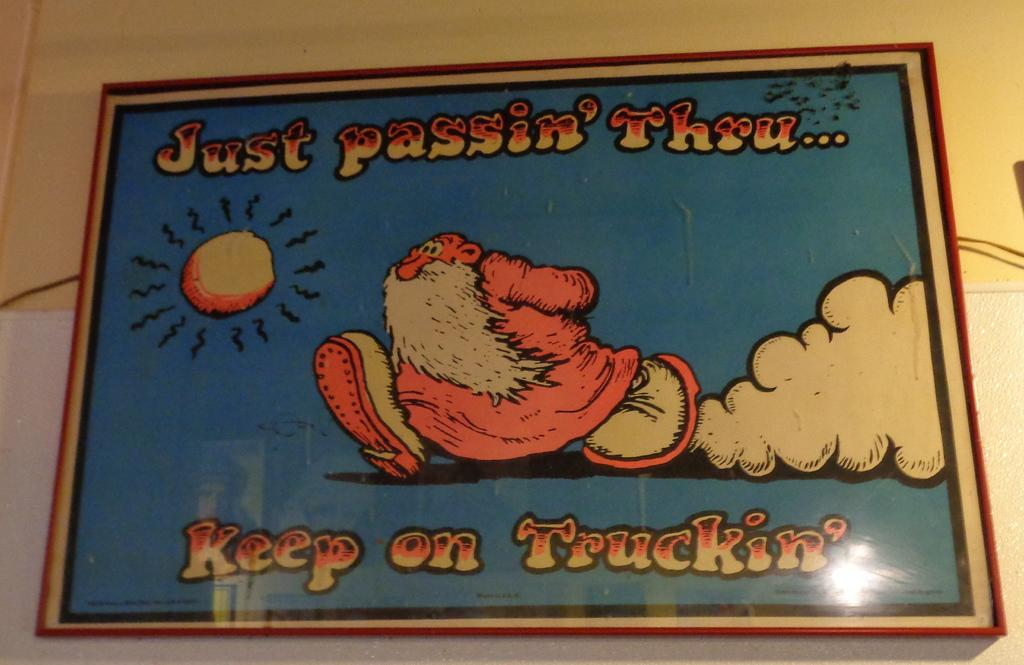<image>
Offer a succinct explanation of the picture presented. A poster of a cartoon with a drawing of a man walking and the words "Just passin' thru... Keep on truckin'" 